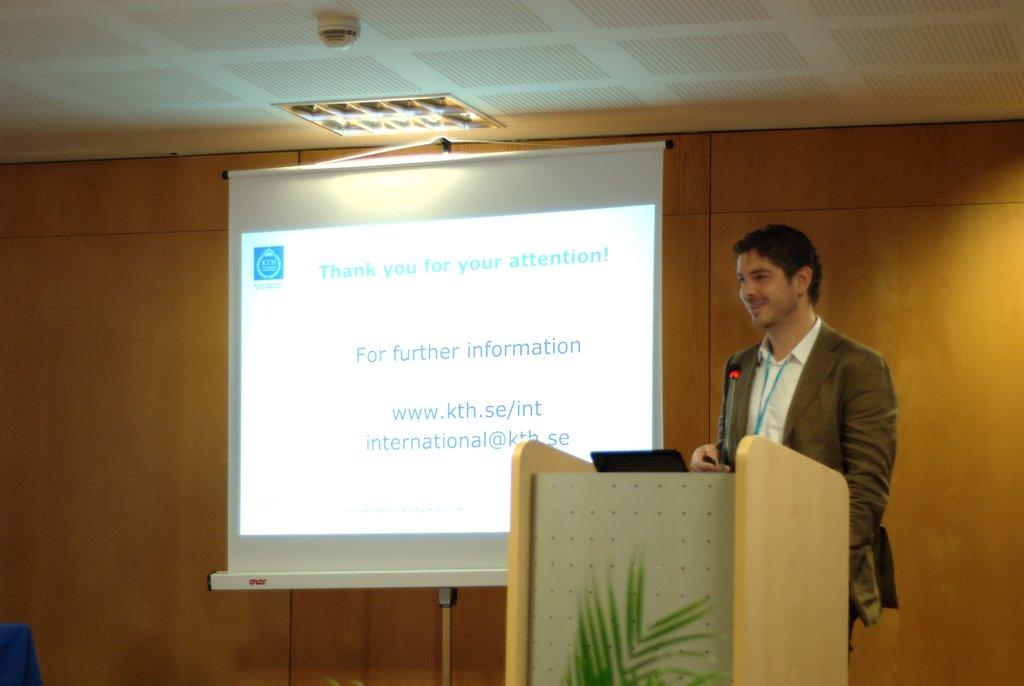What is the website on the powerpoint?
Provide a succinct answer. Www.kth.se/int. 